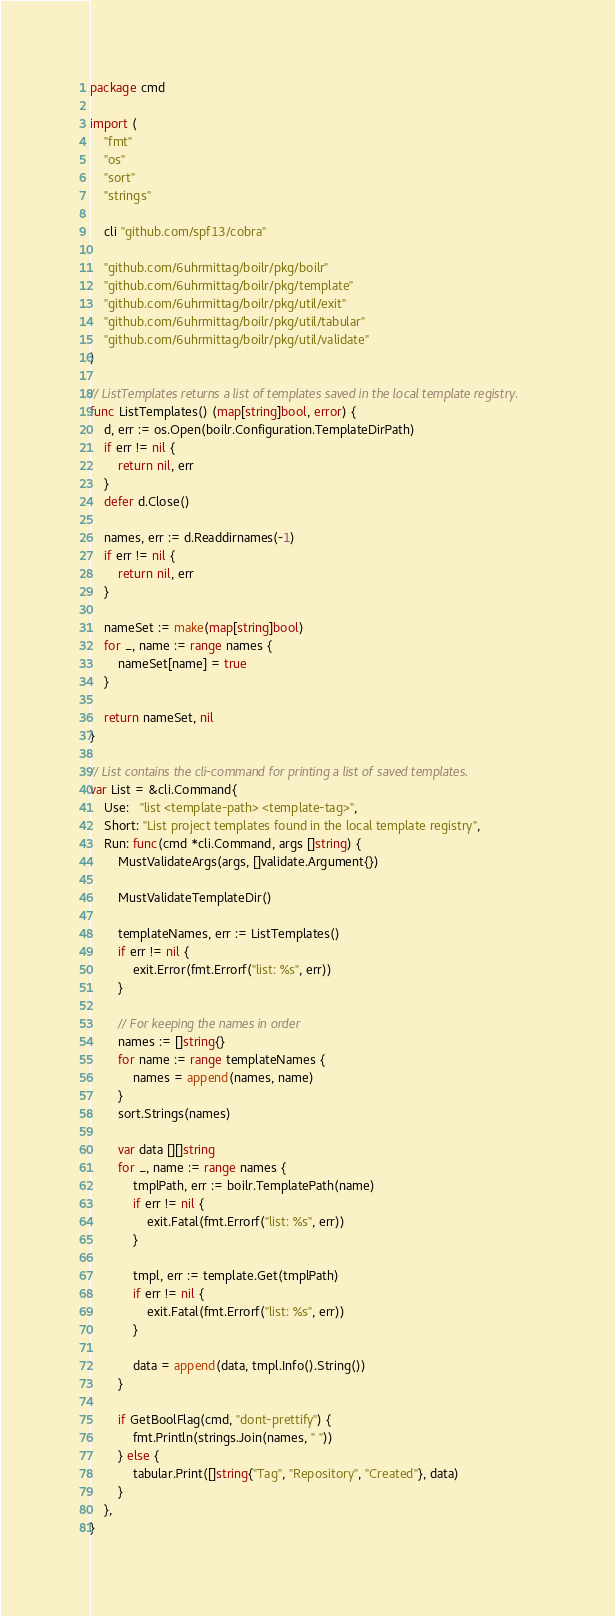Convert code to text. <code><loc_0><loc_0><loc_500><loc_500><_Go_>package cmd

import (
	"fmt"
	"os"
	"sort"
	"strings"

	cli "github.com/spf13/cobra"

	"github.com/6uhrmittag/boilr/pkg/boilr"
	"github.com/6uhrmittag/boilr/pkg/template"
	"github.com/6uhrmittag/boilr/pkg/util/exit"
	"github.com/6uhrmittag/boilr/pkg/util/tabular"
	"github.com/6uhrmittag/boilr/pkg/util/validate"
)

// ListTemplates returns a list of templates saved in the local template registry.
func ListTemplates() (map[string]bool, error) {
	d, err := os.Open(boilr.Configuration.TemplateDirPath)
	if err != nil {
		return nil, err
	}
	defer d.Close()

	names, err := d.Readdirnames(-1)
	if err != nil {
		return nil, err
	}

	nameSet := make(map[string]bool)
	for _, name := range names {
		nameSet[name] = true
	}

	return nameSet, nil
}

// List contains the cli-command for printing a list of saved templates.
var List = &cli.Command{
	Use:   "list <template-path> <template-tag>",
	Short: "List project templates found in the local template registry",
	Run: func(cmd *cli.Command, args []string) {
		MustValidateArgs(args, []validate.Argument{})

		MustValidateTemplateDir()

		templateNames, err := ListTemplates()
		if err != nil {
			exit.Error(fmt.Errorf("list: %s", err))
		}

		// For keeping the names in order
		names := []string{}
		for name := range templateNames {
			names = append(names, name)
		}
		sort.Strings(names)

		var data [][]string
		for _, name := range names {
			tmplPath, err := boilr.TemplatePath(name)
			if err != nil {
				exit.Fatal(fmt.Errorf("list: %s", err))
			}

			tmpl, err := template.Get(tmplPath)
			if err != nil {
				exit.Fatal(fmt.Errorf("list: %s", err))
			}

			data = append(data, tmpl.Info().String())
		}

		if GetBoolFlag(cmd, "dont-prettify") {
			fmt.Println(strings.Join(names, " "))
		} else {
			tabular.Print([]string{"Tag", "Repository", "Created"}, data)
		}
	},
}
</code> 